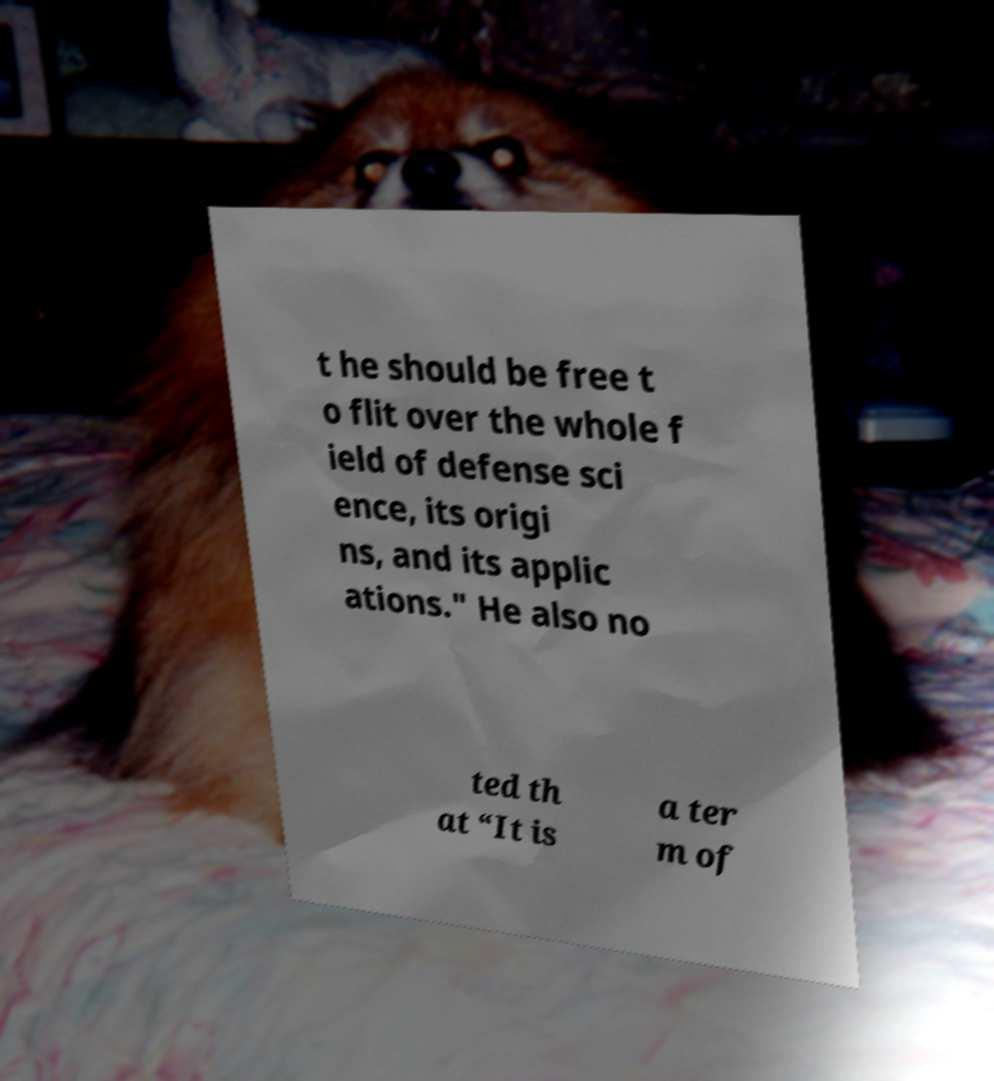There's text embedded in this image that I need extracted. Can you transcribe it verbatim? t he should be free t o flit over the whole f ield of defense sci ence, its origi ns, and its applic ations." He also no ted th at “It is a ter m of 